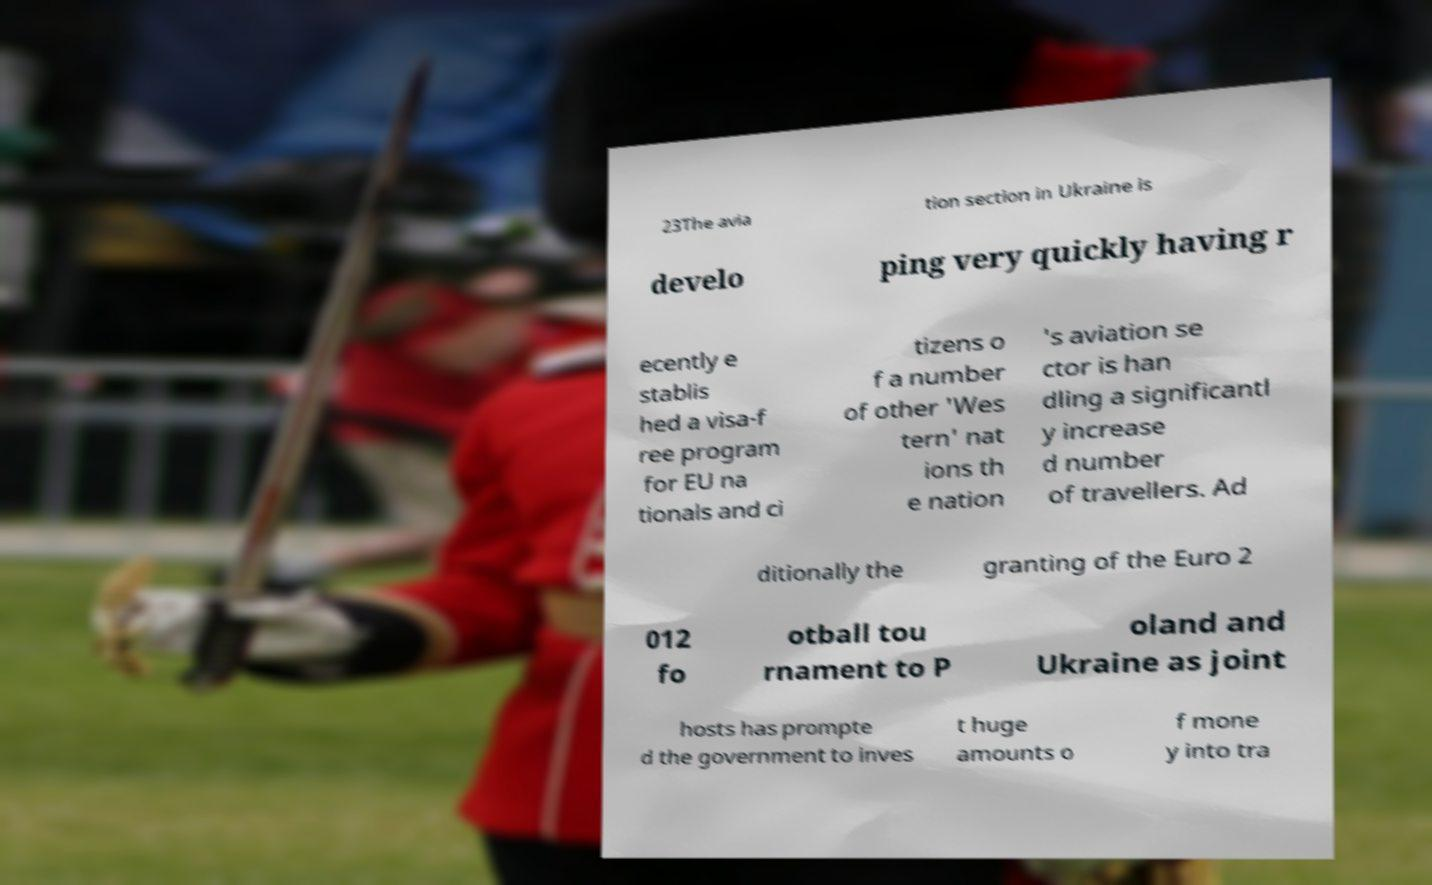For documentation purposes, I need the text within this image transcribed. Could you provide that? 23The avia tion section in Ukraine is develo ping very quickly having r ecently e stablis hed a visa-f ree program for EU na tionals and ci tizens o f a number of other 'Wes tern' nat ions th e nation 's aviation se ctor is han dling a significantl y increase d number of travellers. Ad ditionally the granting of the Euro 2 012 fo otball tou rnament to P oland and Ukraine as joint hosts has prompte d the government to inves t huge amounts o f mone y into tra 